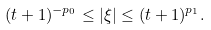<formula> <loc_0><loc_0><loc_500><loc_500>( t + 1 ) ^ { - p _ { 0 } } \leq | \xi | \leq ( t + 1 ) ^ { p _ { 1 } } .</formula> 